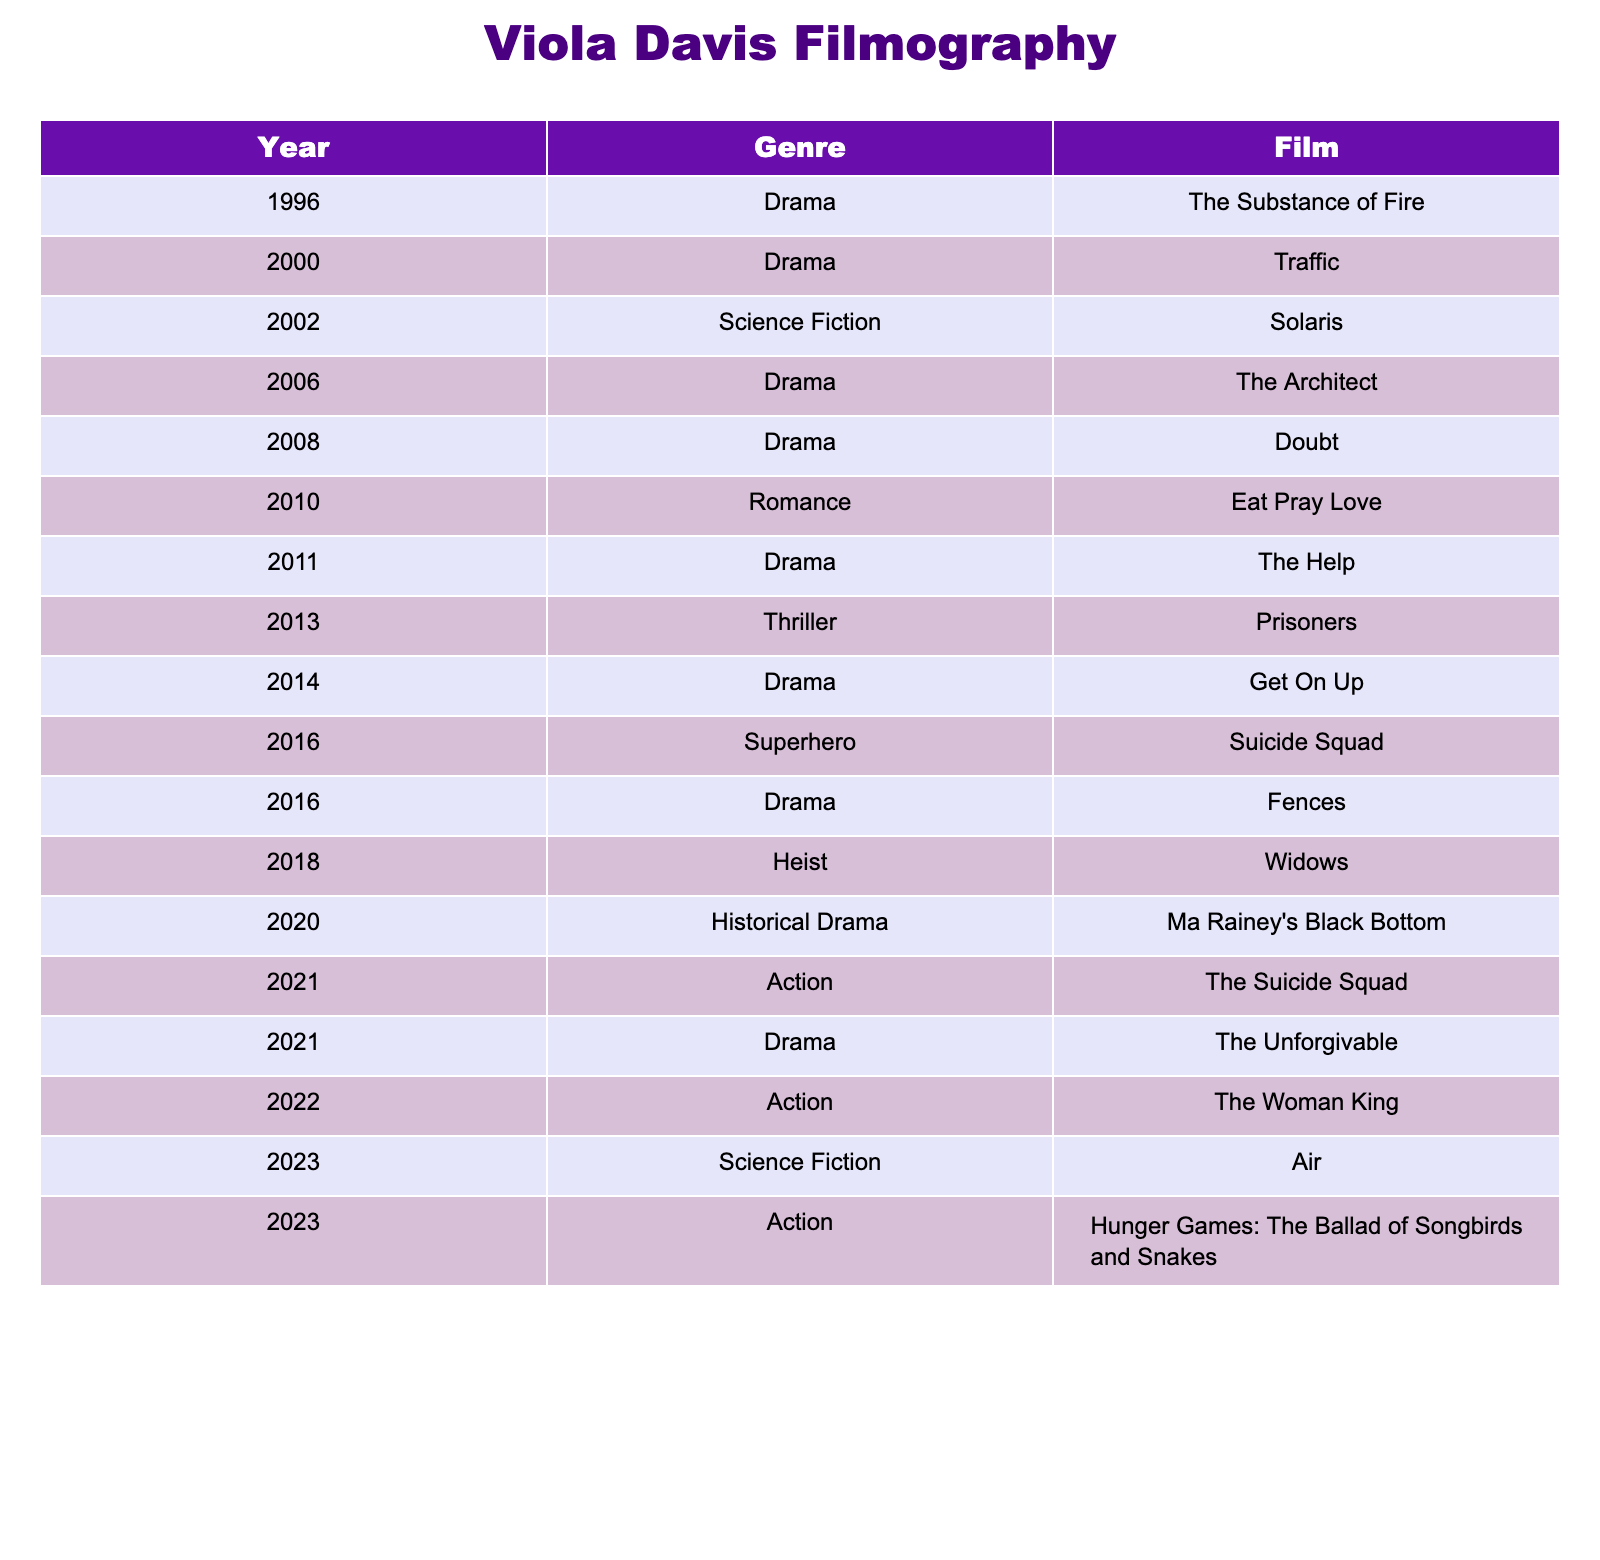What is the most recent film featuring Viola Davis? The table lists films in chronological order by year. The last film in the table is "Hunger Games: The Ballad of Songbirds and Snakes," released in 2023.
Answer: Hunger Games: The Ballad of Songbirds and Snakes How many films did Viola Davis release in the Drama genre? The table shows that there are 7 films classified under the Drama genre. They are: "The Substance of Fire," "Traffic," "The Architect," "Doubt," "The Help," "Get On Up," and "Fences."
Answer: 7 Is "Solaris" a film in the Science Fiction genre? The table indicates that "Solaris" is indeed categorized under the Science Fiction genre, released in 2002.
Answer: Yes How many total genres are represented in the table? To determine the number of genres, we can look through the list of genres in the table, which are Drama, Science Fiction, Romance, Thriller, Superhero, Heist, Historical Drama, and Action. This yields a total of 8 distinct genres.
Answer: 8 Which Drama film was released in 2011? By inspecting the table, the Drama film listed for 2011 is "The Help."
Answer: The Help What percentage of Viola Davis' films are in the Action genre? There are 3 Action films: "The Suicide Squad" (2021), "The Woman King" (2022), and "Hunger Games: The Ballad of Songbirds and Snakes" (2023). Since there are 15 total films, the percentage is (3/15) * 100 = 20%.
Answer: 20% Which year saw the release of the most films featuring Viola Davis, and how many were released that year? By analyzing the table, the year 2016 had two films: "Suicide Squad" and "Fences." This is the highest count for any single year listed.
Answer: 2016, 2 films What is the genre of the film "Ma Rainey's Black Bottom"? The table states that "Ma Rainey's Black Bottom," released in 2020, falls under the Historical Drama genre.
Answer: Historical Drama Which two films were released in 2023? The table shows that "Air" and "Hunger Games: The Ballad of Songbirds and Snakes" were both released in 2023.
Answer: Air, Hunger Games: The Ballad of Songbirds and Snakes Between 2010 and 2013, how many films were released? The films released in that time frame are "Eat Pray Love" (2010), "The Help" (2011), and "Prisoners" (2013), totaling 3 films.
Answer: 3 